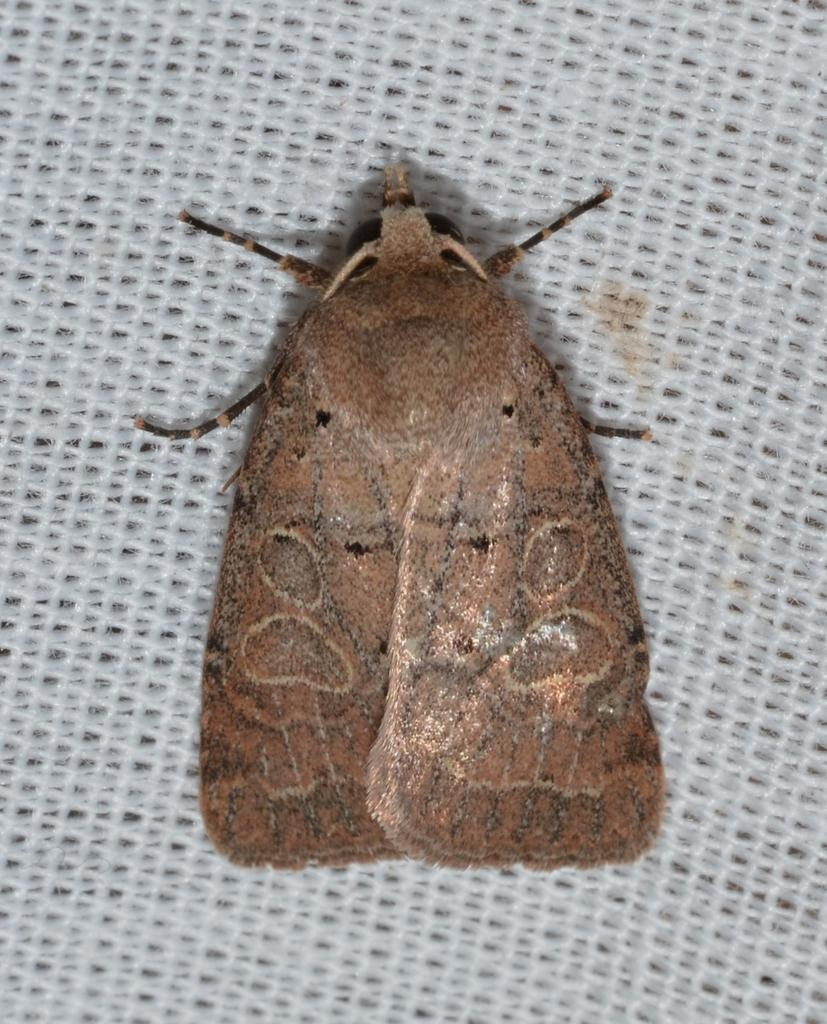What type of creature can be seen in the image? There is an insect in the image. What is the color of the surface where the insect is located? The insect is on a white color surface. How many apples are visible in the scene? There are no apples present in the image. What type of animal can be seen interacting with the insect in the image? There is no animal present in the image; only the insect is visible. 